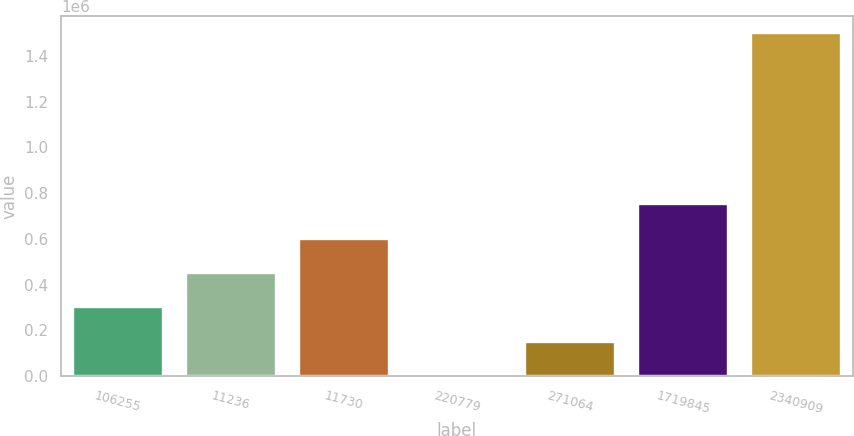<chart> <loc_0><loc_0><loc_500><loc_500><bar_chart><fcel>106255<fcel>11236<fcel>11730<fcel>220779<fcel>271064<fcel>1719845<fcel>2340909<nl><fcel>300135<fcel>450187<fcel>600239<fcel>31<fcel>150083<fcel>750292<fcel>1.50055e+06<nl></chart> 